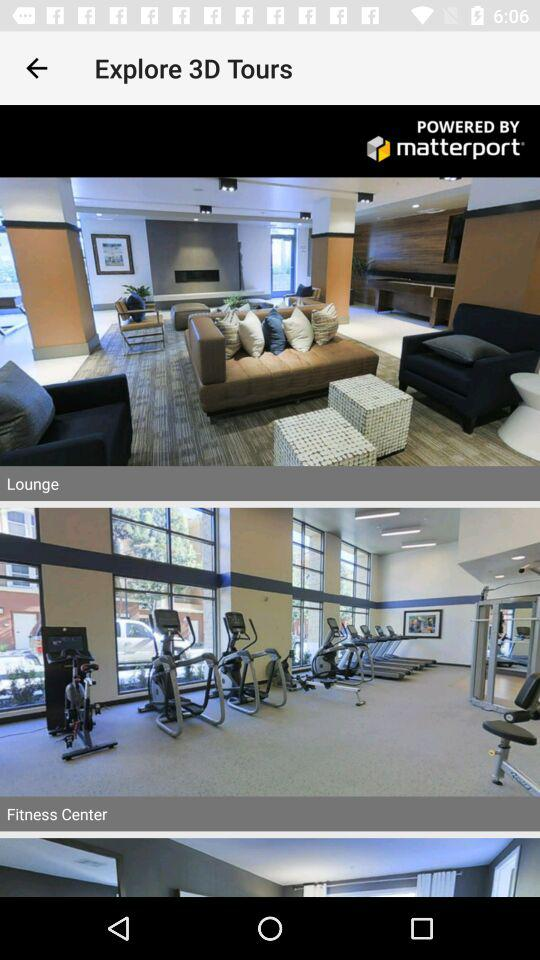"Explore 3D Tours" is powered by whom? "Explore 3D Tours" is powered by "matterport". 